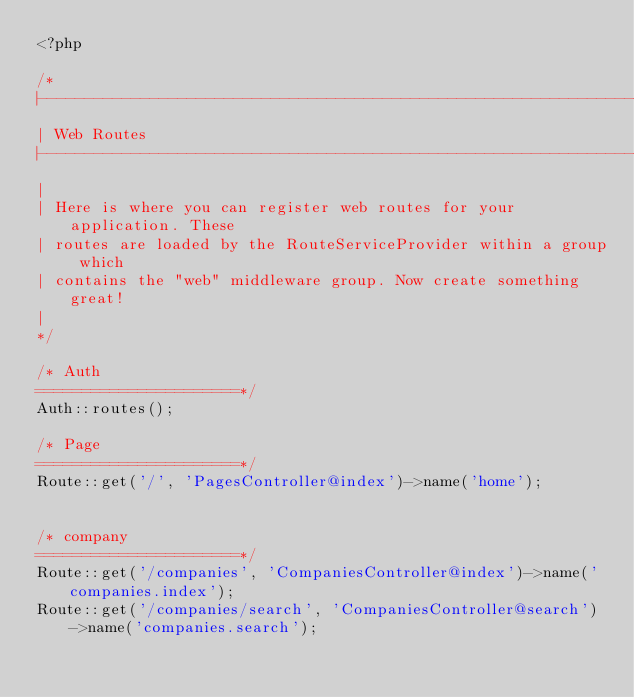Convert code to text. <code><loc_0><loc_0><loc_500><loc_500><_PHP_><?php

/*
|--------------------------------------------------------------------------
| Web Routes
|--------------------------------------------------------------------------
|
| Here is where you can register web routes for your application. These
| routes are loaded by the RouteServiceProvider within a group which
| contains the "web" middleware group. Now create something great!
|
*/

/* Auth
======================*/
Auth::routes();

/* Page
======================*/
Route::get('/', 'PagesController@index')->name('home');


/* company
======================*/
Route::get('/companies', 'CompaniesController@index')->name('companies.index');
Route::get('/companies/search', 'CompaniesController@search')->name('companies.search');
</code> 